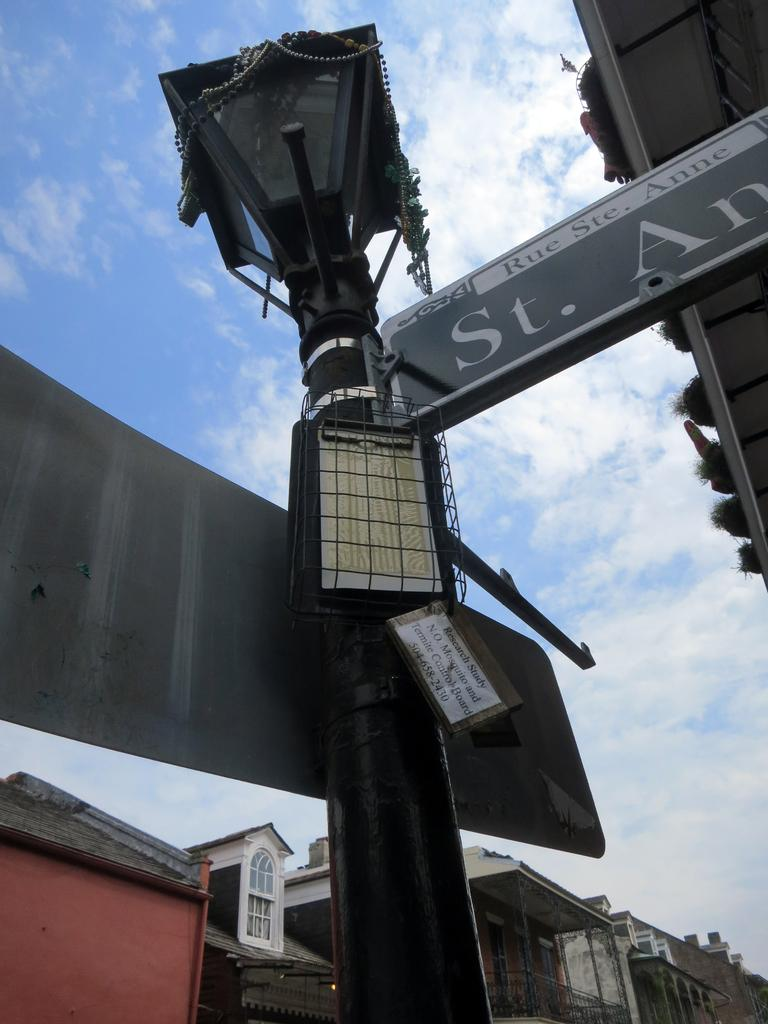What is the main object in the image? There is a pole with directional boards in the image. What is attached to the pole? There is a light on the pole. What can be seen in the background of the image? There are buildings and the sky visible in the background of the image. Can you tell me where the library is located in the image? There is no library present in the image; it only features a pole with directional boards, a light, buildings, and the sky in the background. Is there a tiger visible in the image? No, there is no tiger present in the image. 